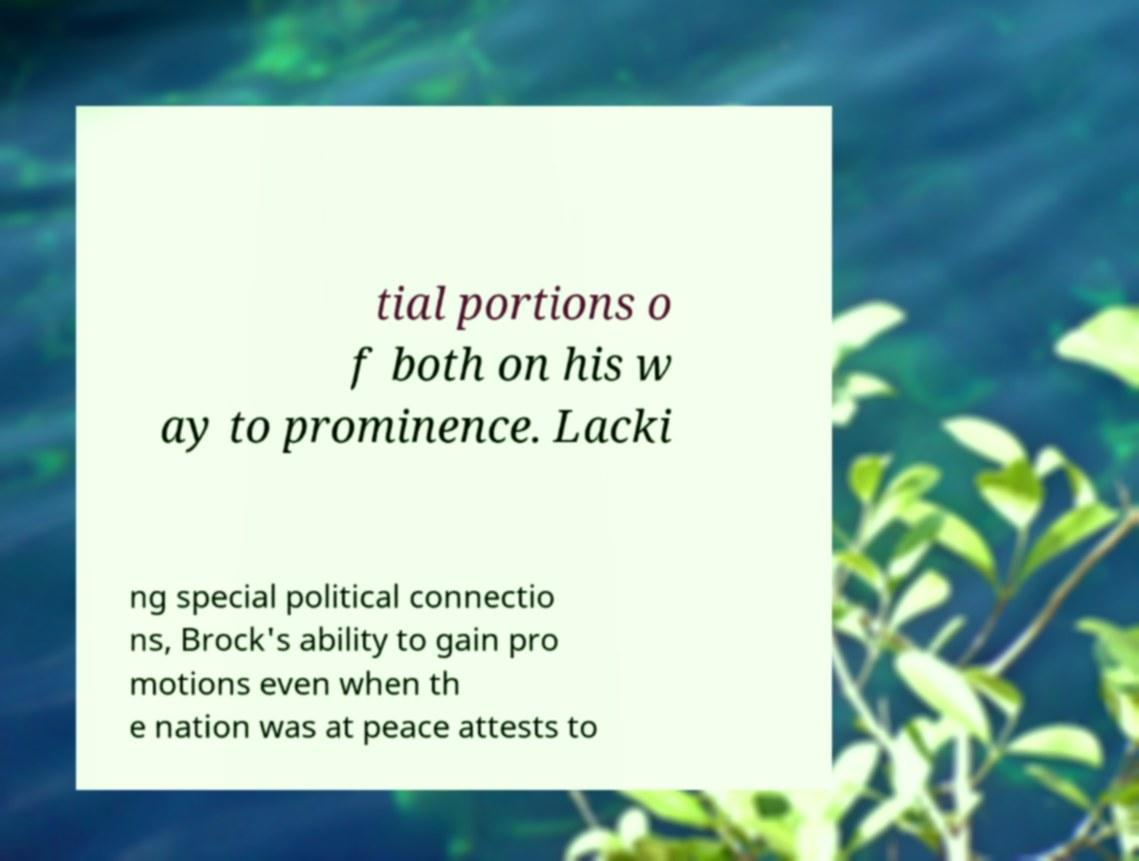For documentation purposes, I need the text within this image transcribed. Could you provide that? tial portions o f both on his w ay to prominence. Lacki ng special political connectio ns, Brock's ability to gain pro motions even when th e nation was at peace attests to 